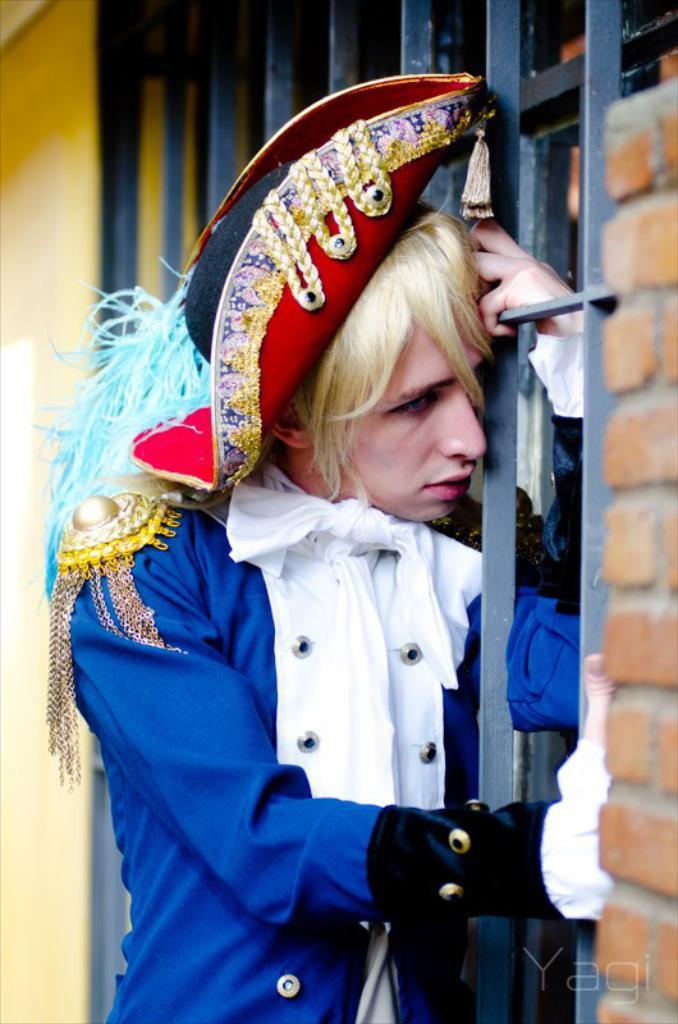Who or what is the main subject in the image? There is a person in the image. What is the person wearing? The person is wearing a fancy dress. What can be seen behind the person? There are iron grills behind the person. What is located behind the iron grills? There is a wall behind the iron grills. What sense does the person in the image have that allows them to feel the texture of their skin? The image does not provide information about the person's senses or their ability to feel the texture of their skin. 